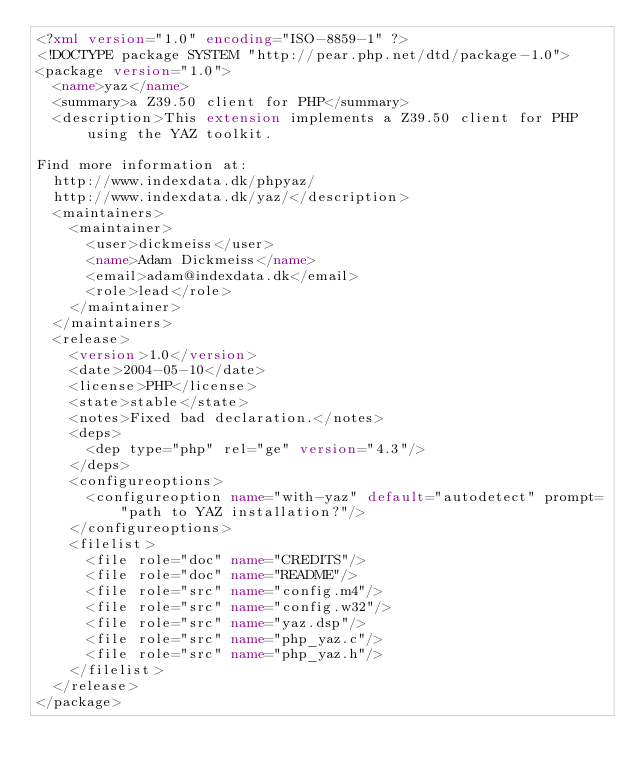<code> <loc_0><loc_0><loc_500><loc_500><_XML_><?xml version="1.0" encoding="ISO-8859-1" ?>
<!DOCTYPE package SYSTEM "http://pear.php.net/dtd/package-1.0">
<package version="1.0">
  <name>yaz</name>
  <summary>a Z39.50 client for PHP</summary>
  <description>This extension implements a Z39.50 client for PHP using the YAZ toolkit.

Find more information at:
  http://www.indexdata.dk/phpyaz/
  http://www.indexdata.dk/yaz/</description>
  <maintainers>
    <maintainer>
      <user>dickmeiss</user>
      <name>Adam Dickmeiss</name>
      <email>adam@indexdata.dk</email>
      <role>lead</role>
    </maintainer>
  </maintainers>
  <release>
    <version>1.0</version>
    <date>2004-05-10</date>
    <license>PHP</license>
    <state>stable</state>
    <notes>Fixed bad declaration.</notes>
    <deps>
      <dep type="php" rel="ge" version="4.3"/>
    </deps>
    <configureoptions>
      <configureoption name="with-yaz" default="autodetect" prompt="path to YAZ installation?"/>
    </configureoptions>
    <filelist>
      <file role="doc" name="CREDITS"/>
      <file role="doc" name="README"/>
      <file role="src" name="config.m4"/>
      <file role="src" name="config.w32"/>
      <file role="src" name="yaz.dsp"/>
      <file role="src" name="php_yaz.c"/>
      <file role="src" name="php_yaz.h"/>
    </filelist>
  </release>
</package>
</code> 